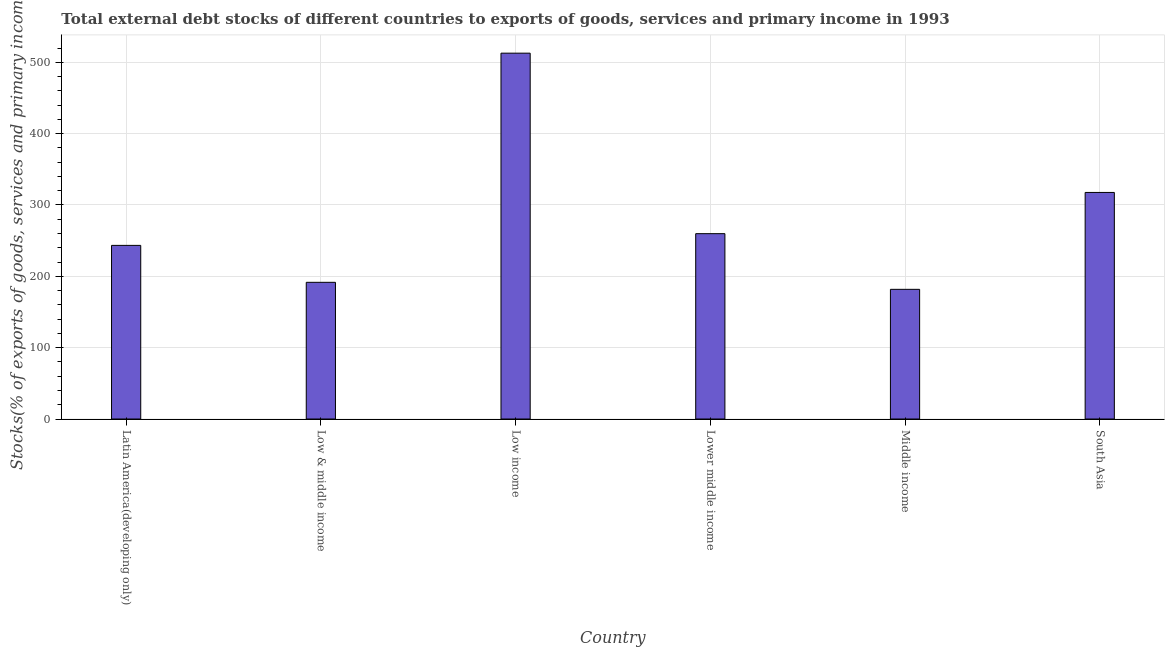What is the title of the graph?
Ensure brevity in your answer.  Total external debt stocks of different countries to exports of goods, services and primary income in 1993. What is the label or title of the Y-axis?
Provide a short and direct response. Stocks(% of exports of goods, services and primary income). What is the external debt stocks in Lower middle income?
Your response must be concise. 259.79. Across all countries, what is the maximum external debt stocks?
Give a very brief answer. 512.78. Across all countries, what is the minimum external debt stocks?
Offer a terse response. 181.77. In which country was the external debt stocks maximum?
Your answer should be very brief. Low income. What is the sum of the external debt stocks?
Your response must be concise. 1706.88. What is the difference between the external debt stocks in Latin America(developing only) and Low income?
Provide a short and direct response. -269.41. What is the average external debt stocks per country?
Keep it short and to the point. 284.48. What is the median external debt stocks?
Ensure brevity in your answer.  251.58. What is the ratio of the external debt stocks in Latin America(developing only) to that in Middle income?
Give a very brief answer. 1.34. What is the difference between the highest and the second highest external debt stocks?
Offer a very short reply. 195.21. What is the difference between the highest and the lowest external debt stocks?
Keep it short and to the point. 331.02. How many countries are there in the graph?
Keep it short and to the point. 6. What is the Stocks(% of exports of goods, services and primary income) in Latin America(developing only)?
Your response must be concise. 243.37. What is the Stocks(% of exports of goods, services and primary income) of Low & middle income?
Provide a short and direct response. 191.6. What is the Stocks(% of exports of goods, services and primary income) of Low income?
Your answer should be very brief. 512.78. What is the Stocks(% of exports of goods, services and primary income) in Lower middle income?
Provide a short and direct response. 259.79. What is the Stocks(% of exports of goods, services and primary income) in Middle income?
Ensure brevity in your answer.  181.77. What is the Stocks(% of exports of goods, services and primary income) of South Asia?
Offer a very short reply. 317.57. What is the difference between the Stocks(% of exports of goods, services and primary income) in Latin America(developing only) and Low & middle income?
Offer a terse response. 51.77. What is the difference between the Stocks(% of exports of goods, services and primary income) in Latin America(developing only) and Low income?
Provide a succinct answer. -269.41. What is the difference between the Stocks(% of exports of goods, services and primary income) in Latin America(developing only) and Lower middle income?
Your answer should be compact. -16.42. What is the difference between the Stocks(% of exports of goods, services and primary income) in Latin America(developing only) and Middle income?
Give a very brief answer. 61.6. What is the difference between the Stocks(% of exports of goods, services and primary income) in Latin America(developing only) and South Asia?
Provide a succinct answer. -74.2. What is the difference between the Stocks(% of exports of goods, services and primary income) in Low & middle income and Low income?
Keep it short and to the point. -321.18. What is the difference between the Stocks(% of exports of goods, services and primary income) in Low & middle income and Lower middle income?
Make the answer very short. -68.19. What is the difference between the Stocks(% of exports of goods, services and primary income) in Low & middle income and Middle income?
Ensure brevity in your answer.  9.83. What is the difference between the Stocks(% of exports of goods, services and primary income) in Low & middle income and South Asia?
Your response must be concise. -125.97. What is the difference between the Stocks(% of exports of goods, services and primary income) in Low income and Lower middle income?
Keep it short and to the point. 252.99. What is the difference between the Stocks(% of exports of goods, services and primary income) in Low income and Middle income?
Offer a very short reply. 331.02. What is the difference between the Stocks(% of exports of goods, services and primary income) in Low income and South Asia?
Provide a succinct answer. 195.21. What is the difference between the Stocks(% of exports of goods, services and primary income) in Lower middle income and Middle income?
Keep it short and to the point. 78.02. What is the difference between the Stocks(% of exports of goods, services and primary income) in Lower middle income and South Asia?
Keep it short and to the point. -57.78. What is the difference between the Stocks(% of exports of goods, services and primary income) in Middle income and South Asia?
Ensure brevity in your answer.  -135.8. What is the ratio of the Stocks(% of exports of goods, services and primary income) in Latin America(developing only) to that in Low & middle income?
Your answer should be very brief. 1.27. What is the ratio of the Stocks(% of exports of goods, services and primary income) in Latin America(developing only) to that in Low income?
Your response must be concise. 0.47. What is the ratio of the Stocks(% of exports of goods, services and primary income) in Latin America(developing only) to that in Lower middle income?
Ensure brevity in your answer.  0.94. What is the ratio of the Stocks(% of exports of goods, services and primary income) in Latin America(developing only) to that in Middle income?
Give a very brief answer. 1.34. What is the ratio of the Stocks(% of exports of goods, services and primary income) in Latin America(developing only) to that in South Asia?
Offer a very short reply. 0.77. What is the ratio of the Stocks(% of exports of goods, services and primary income) in Low & middle income to that in Low income?
Provide a succinct answer. 0.37. What is the ratio of the Stocks(% of exports of goods, services and primary income) in Low & middle income to that in Lower middle income?
Your answer should be very brief. 0.74. What is the ratio of the Stocks(% of exports of goods, services and primary income) in Low & middle income to that in Middle income?
Keep it short and to the point. 1.05. What is the ratio of the Stocks(% of exports of goods, services and primary income) in Low & middle income to that in South Asia?
Make the answer very short. 0.6. What is the ratio of the Stocks(% of exports of goods, services and primary income) in Low income to that in Lower middle income?
Provide a succinct answer. 1.97. What is the ratio of the Stocks(% of exports of goods, services and primary income) in Low income to that in Middle income?
Provide a succinct answer. 2.82. What is the ratio of the Stocks(% of exports of goods, services and primary income) in Low income to that in South Asia?
Your response must be concise. 1.61. What is the ratio of the Stocks(% of exports of goods, services and primary income) in Lower middle income to that in Middle income?
Provide a short and direct response. 1.43. What is the ratio of the Stocks(% of exports of goods, services and primary income) in Lower middle income to that in South Asia?
Offer a very short reply. 0.82. What is the ratio of the Stocks(% of exports of goods, services and primary income) in Middle income to that in South Asia?
Provide a short and direct response. 0.57. 